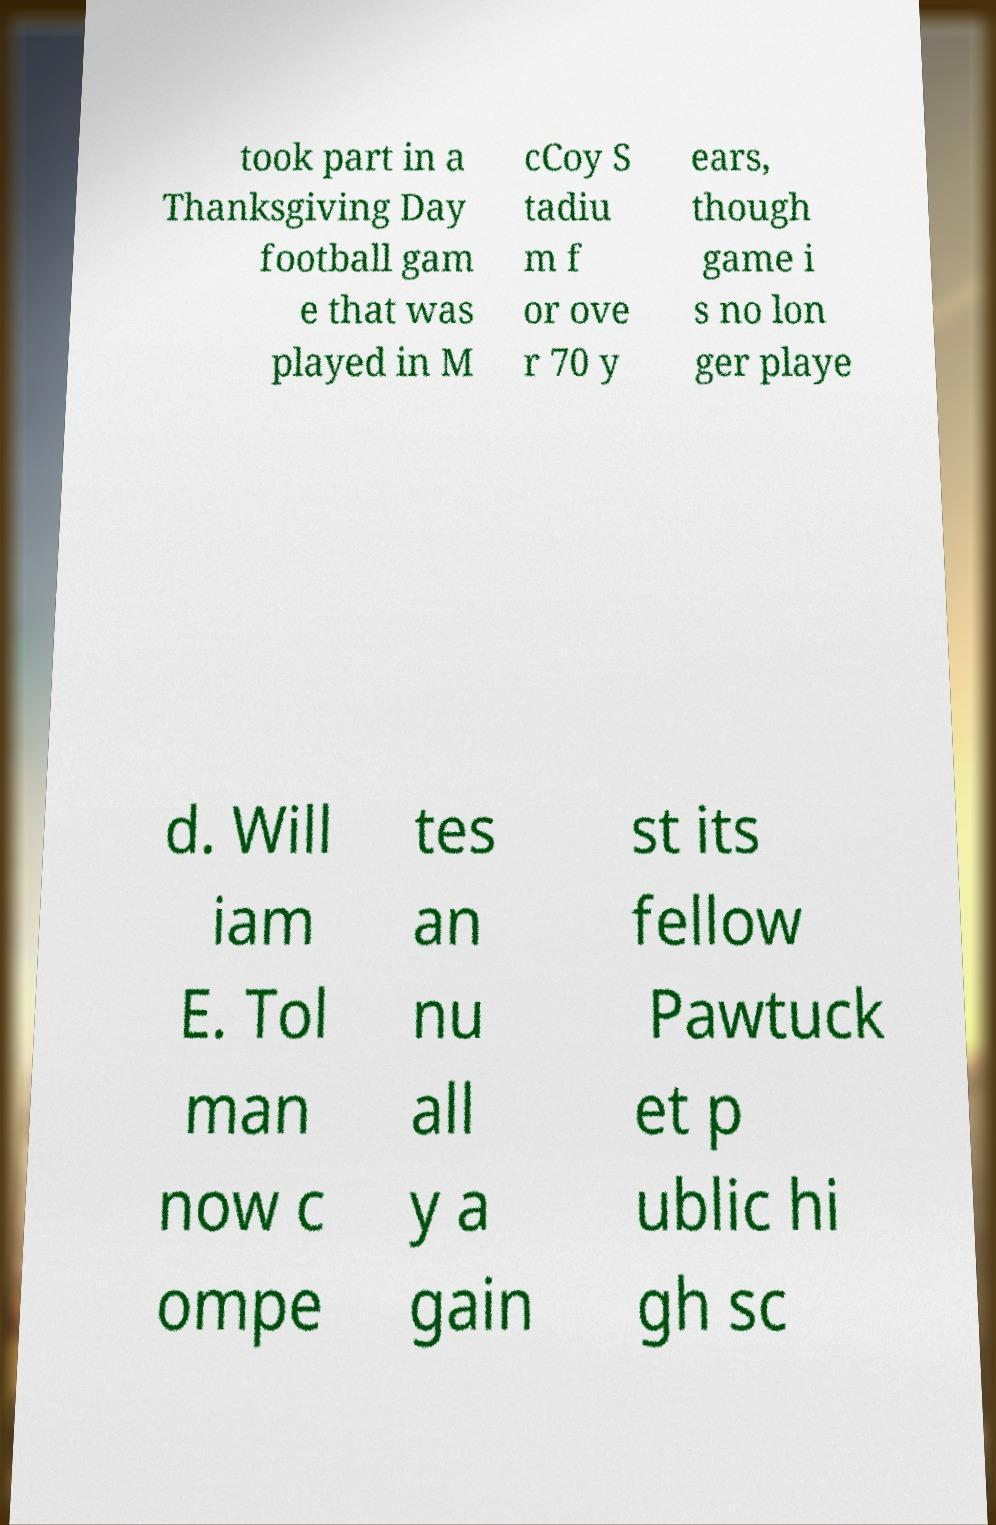Please identify and transcribe the text found in this image. took part in a Thanksgiving Day football gam e that was played in M cCoy S tadiu m f or ove r 70 y ears, though game i s no lon ger playe d. Will iam E. Tol man now c ompe tes an nu all y a gain st its fellow Pawtuck et p ublic hi gh sc 